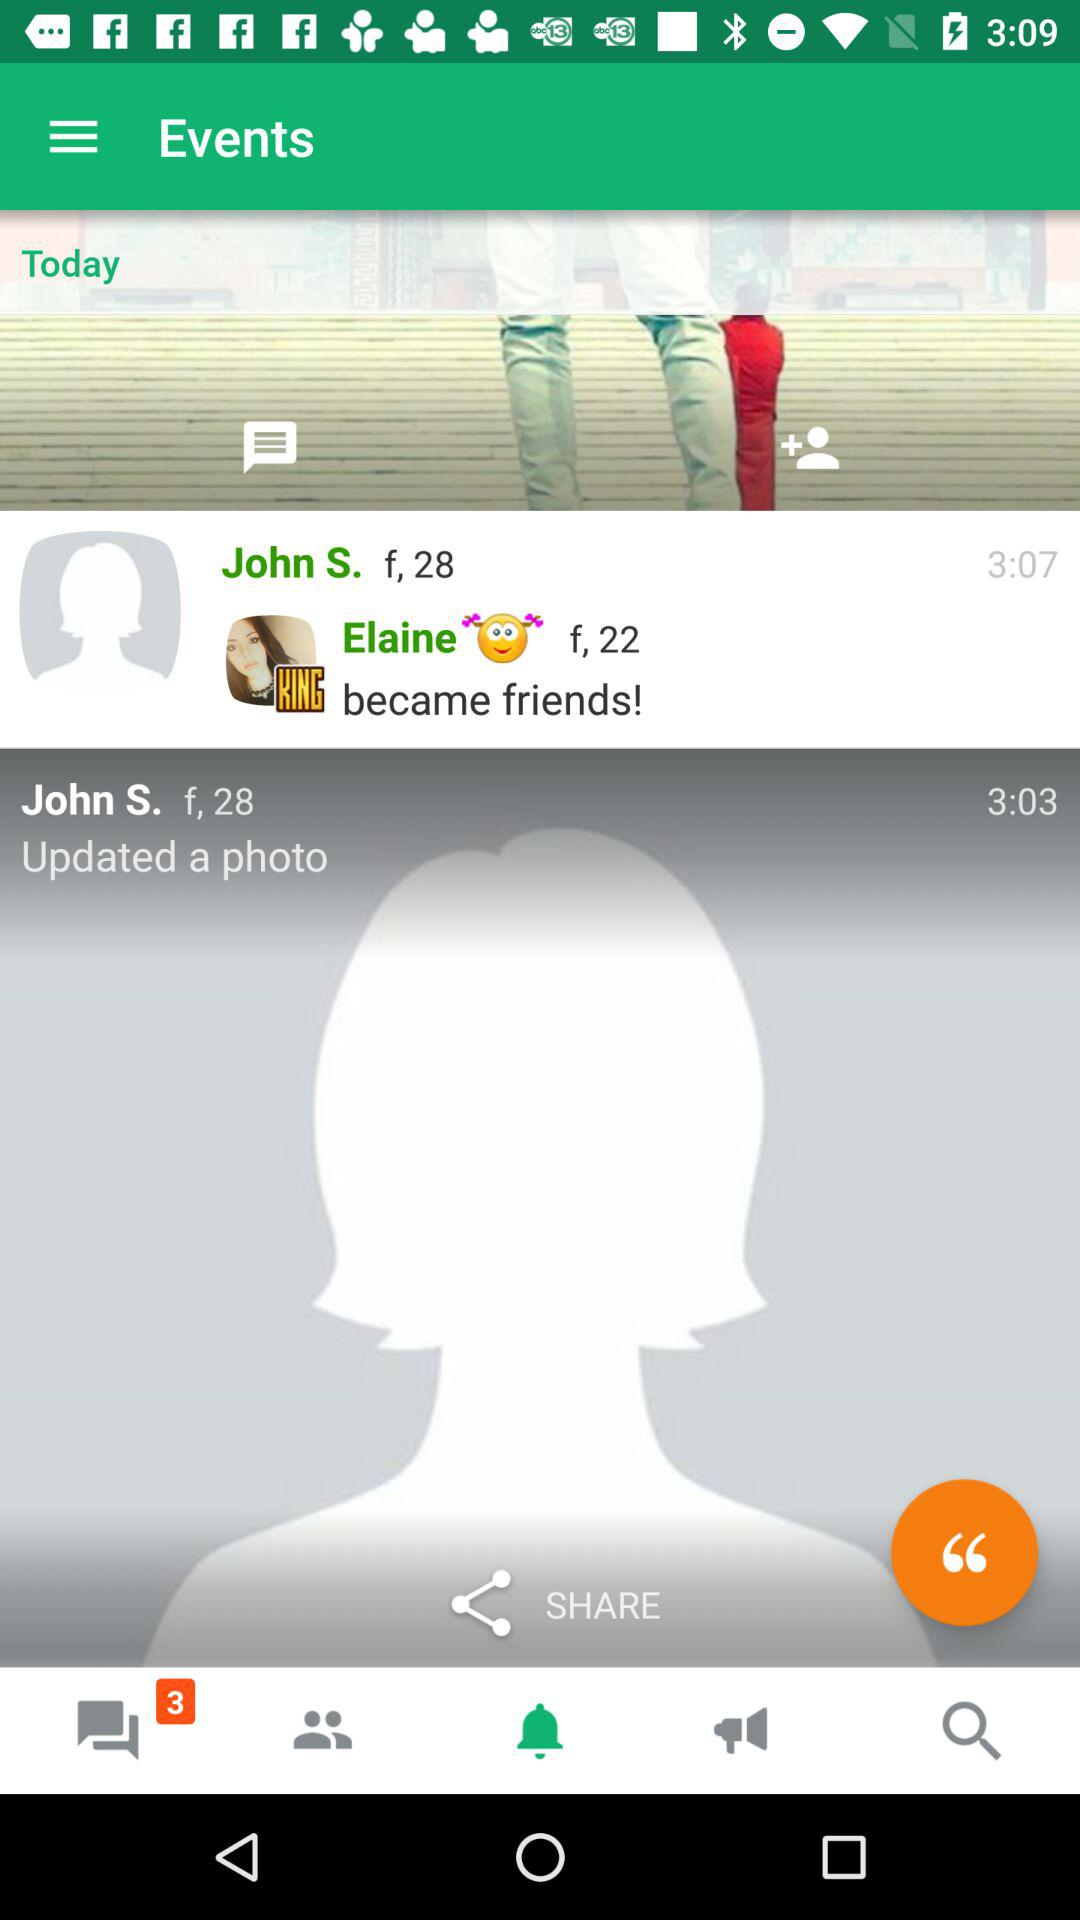What is the gender of Elaine? The gender is female. 